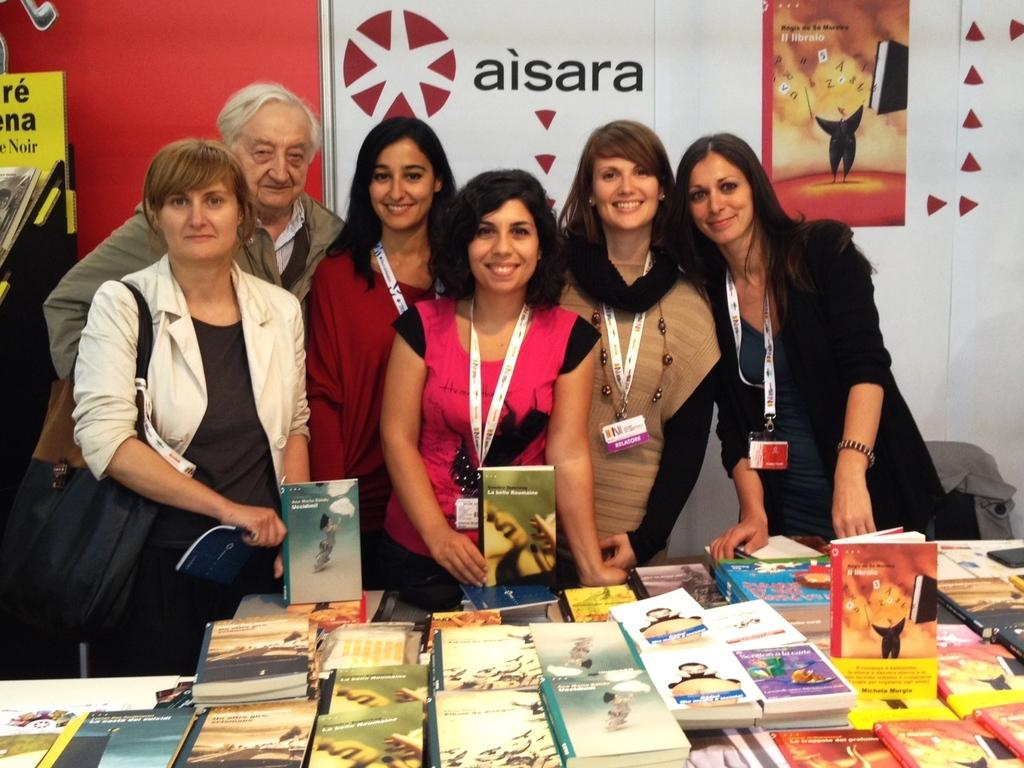<image>
Present a compact description of the photo's key features. Group of people posing in front of a wall that says Aisara. 